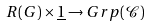Convert formula to latex. <formula><loc_0><loc_0><loc_500><loc_500>R ( G ) \times \underline { 1 } \to G r p ( \mathcal { C } )</formula> 